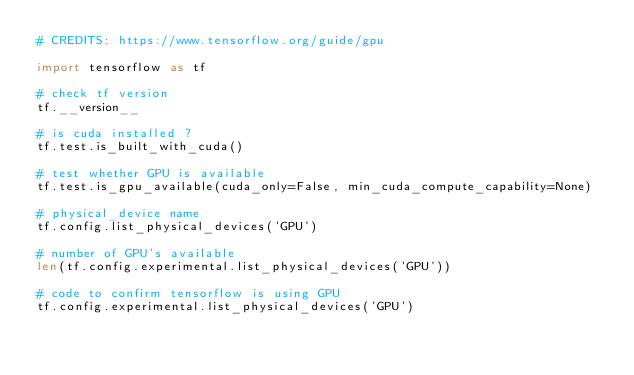<code> <loc_0><loc_0><loc_500><loc_500><_Python_># CREDITS: https://www.tensorflow.org/guide/gpu

import tensorflow as tf

# check tf version
tf.__version__

# is cuda installed ?
tf.test.is_built_with_cuda()

# test whether GPU is available
tf.test.is_gpu_available(cuda_only=False, min_cuda_compute_capability=None)

# physical_device name
tf.config.list_physical_devices('GPU')

# number of GPU's available
len(tf.config.experimental.list_physical_devices('GPU'))

# code to confirm tensorflow is using GPU
tf.config.experimental.list_physical_devices('GPU')</code> 